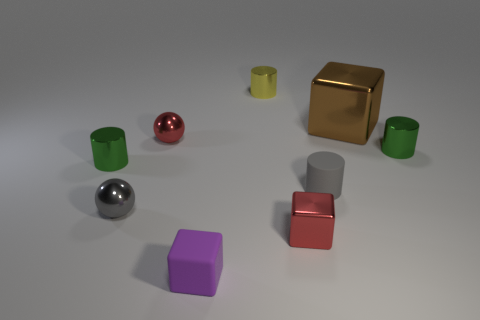Subtract all tiny cubes. How many cubes are left? 1 Subtract all blue cubes. How many green cylinders are left? 2 Subtract all cylinders. How many objects are left? 5 Subtract all brown cubes. How many cubes are left? 2 Subtract 3 blocks. How many blocks are left? 0 Subtract all green spheres. Subtract all yellow blocks. How many spheres are left? 2 Subtract all metallic objects. Subtract all big brown metal blocks. How many objects are left? 1 Add 9 yellow cylinders. How many yellow cylinders are left? 10 Add 8 red objects. How many red objects exist? 10 Subtract 0 green spheres. How many objects are left? 9 